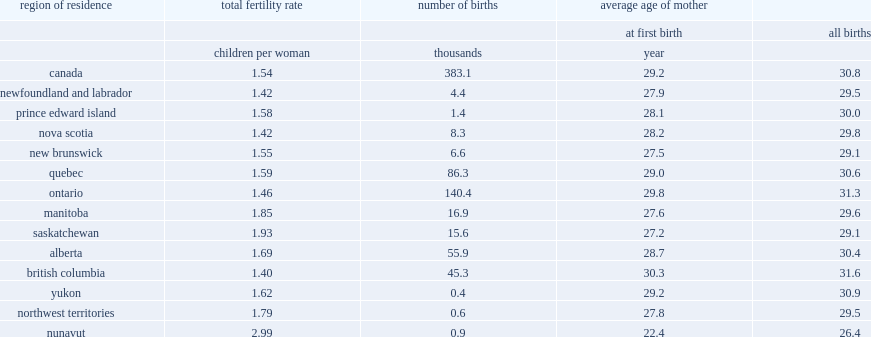What was the number of children per woman did nunavut have a total fertility rate above replacement level among the provinces and territories? 2.99. What was the total fertility rate in saskatchewan? 1.93. What was the total fertility rate in manitoba? 1.85. What was the total fertility rate in the northwest territories? 1.79. Which region of residence had the lowest total fertility rate? British columbia. What was the average age of first-time mothers in 2016? 29.2. Which region of residence had the oldest average age of first-time mothers among the provinces and territories? 30.3. Which region of residence had an average age of mother at first birth (29.8 years) that was above the overall age for canada? Ontario. Which region of residence had the youngest average age of mothers at first birth? Nunavut. 